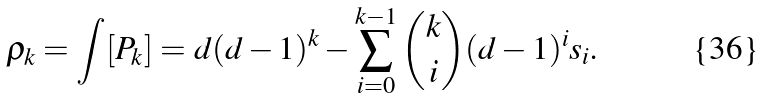<formula> <loc_0><loc_0><loc_500><loc_500>\varrho _ { k } = \int [ P _ { k } ] = d ( d - 1 ) ^ { k } - \sum _ { i = 0 } ^ { k - 1 } \binom { k } { i } ( d - 1 ) ^ { i } s _ { i } .</formula> 